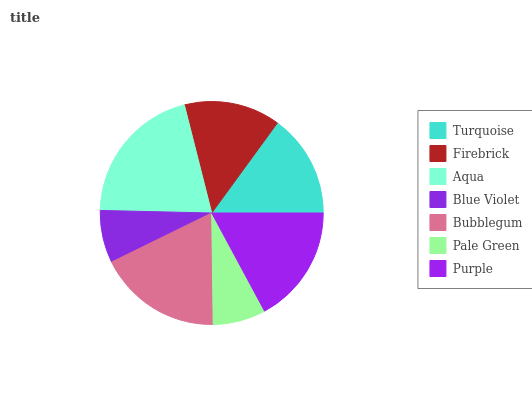Is Blue Violet the minimum?
Answer yes or no. Yes. Is Aqua the maximum?
Answer yes or no. Yes. Is Firebrick the minimum?
Answer yes or no. No. Is Firebrick the maximum?
Answer yes or no. No. Is Turquoise greater than Firebrick?
Answer yes or no. Yes. Is Firebrick less than Turquoise?
Answer yes or no. Yes. Is Firebrick greater than Turquoise?
Answer yes or no. No. Is Turquoise less than Firebrick?
Answer yes or no. No. Is Turquoise the high median?
Answer yes or no. Yes. Is Turquoise the low median?
Answer yes or no. Yes. Is Blue Violet the high median?
Answer yes or no. No. Is Pale Green the low median?
Answer yes or no. No. 